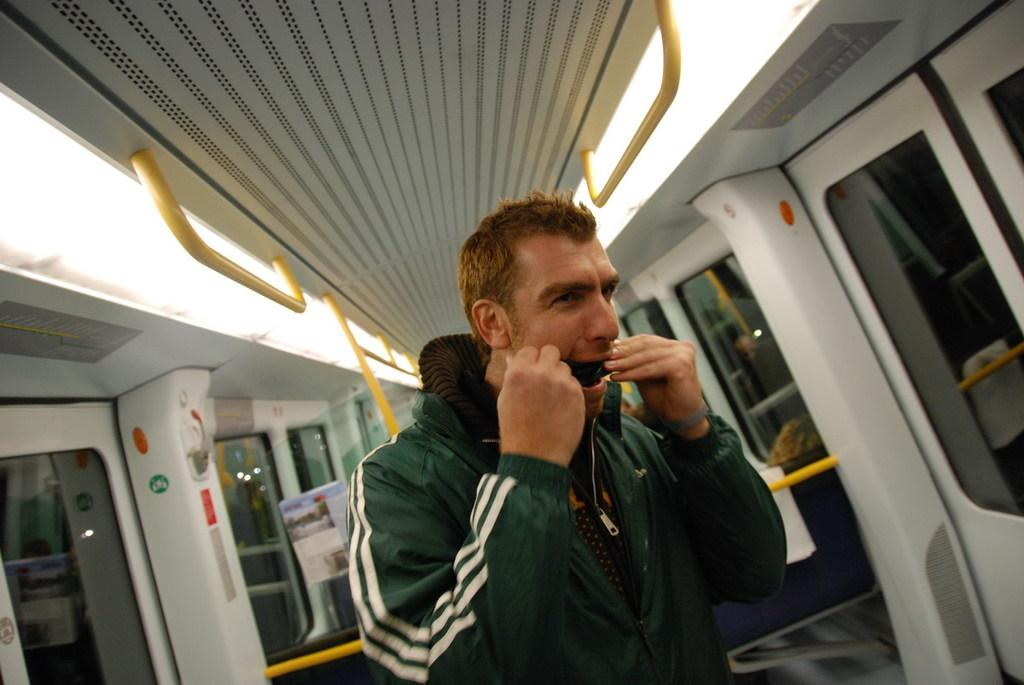What is the man in the image doing? The man is standing in a vehicle. What can be seen in the background of the image? There are doors in the background of the image. What is located at the top of the image? There are rods at the top of the image. What object is visible in the image? There is a board visible in the image. What type of brass material can be seen on the board in the image? There is no brass material present on the board in the image. 